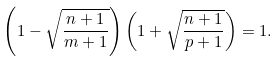Convert formula to latex. <formula><loc_0><loc_0><loc_500><loc_500>\left ( 1 - \sqrt { \frac { n + 1 } { m + 1 } } \right ) \left ( 1 + \sqrt { \frac { n + 1 } { p + 1 } } \right ) = 1 .</formula> 